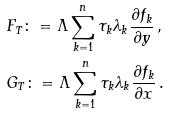<formula> <loc_0><loc_0><loc_500><loc_500>& F _ { T } \colon = \Lambda \sum _ { k = 1 } ^ { n } \tau _ { k } \lambda _ { k } \frac { \partial f _ { k } } { \partial y } \, , \\ & G _ { T } \colon = \Lambda \sum _ { k = 1 } ^ { n } \tau _ { k } \lambda _ { k } \frac { \partial f _ { k } } { \partial x } \, .</formula> 